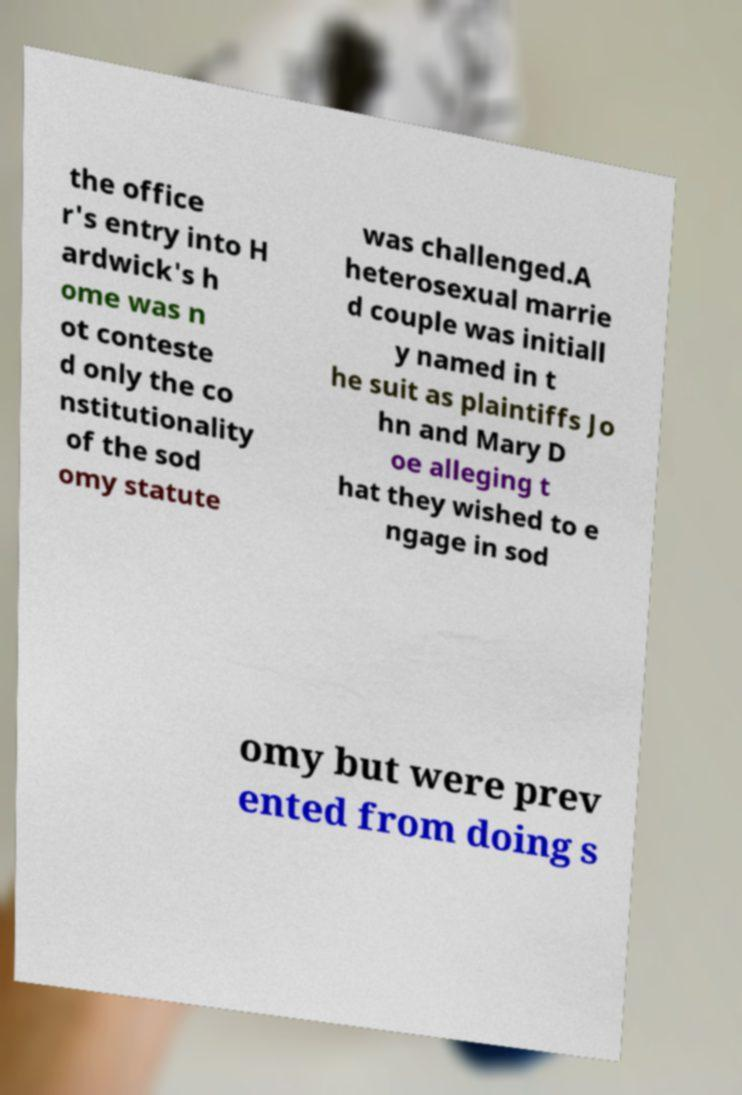There's text embedded in this image that I need extracted. Can you transcribe it verbatim? the office r's entry into H ardwick's h ome was n ot conteste d only the co nstitutionality of the sod omy statute was challenged.A heterosexual marrie d couple was initiall y named in t he suit as plaintiffs Jo hn and Mary D oe alleging t hat they wished to e ngage in sod omy but were prev ented from doing s 